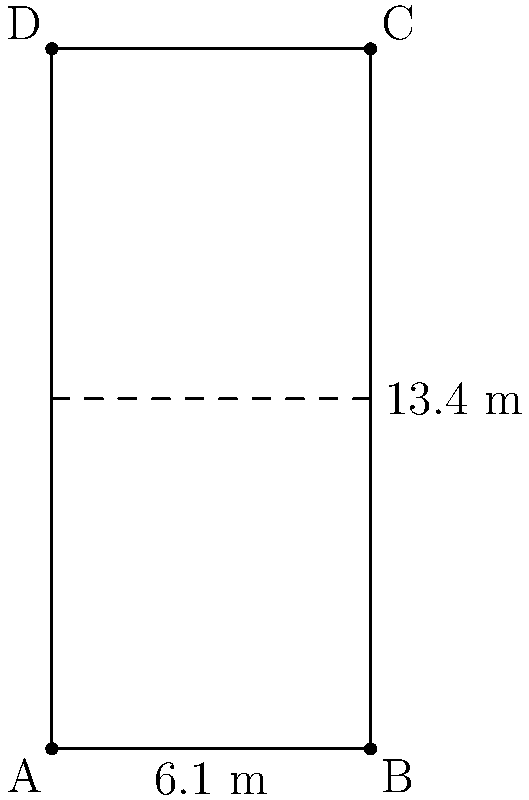In a badminton court, the corners are represented by points A(0,0), B(6.1,0), C(6.1,13.4), and D(0,13.4) in meters. Calculate the distance between points A and C, which represents the diagonal length of the court. To find the distance between points A and C, we can use the distance formula:

$$d = \sqrt{(x_2-x_1)^2 + (y_2-y_1)^2}$$

Where $(x_1,y_1)$ are the coordinates of point A, and $(x_2,y_2)$ are the coordinates of point C.

Step 1: Identify the coordinates
A: $(x_1,y_1) = (0,0)$
C: $(x_2,y_2) = (6.1,13.4)$

Step 2: Plug the values into the distance formula
$$d = \sqrt{(6.1-0)^2 + (13.4-0)^2}$$

Step 3: Simplify the expression under the square root
$$d = \sqrt{6.1^2 + 13.4^2}$$

Step 4: Calculate the squares
$$d = \sqrt{37.21 + 179.56}$$

Step 5: Add the values under the square root
$$d = \sqrt{216.77}$$

Step 6: Calculate the square root
$$d \approx 14.72$$

Therefore, the distance between points A and C is approximately 14.72 meters.
Answer: 14.72 m 